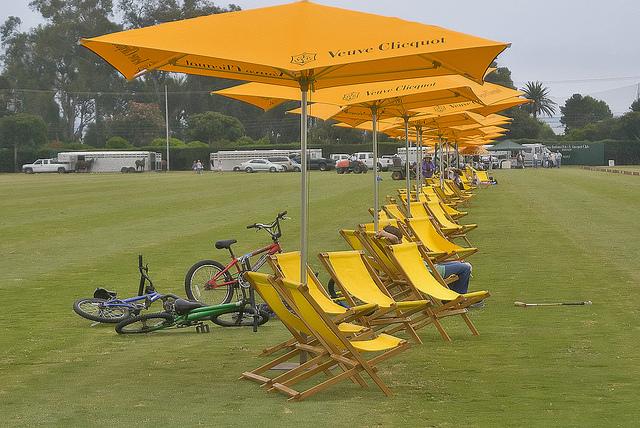Is these beach chairs and umbrellas on a sandy beach?
Answer briefly. No. What color bike still stands?
Quick response, please. Red. How many bicycles are by the chairs?
Write a very short answer. 3. 